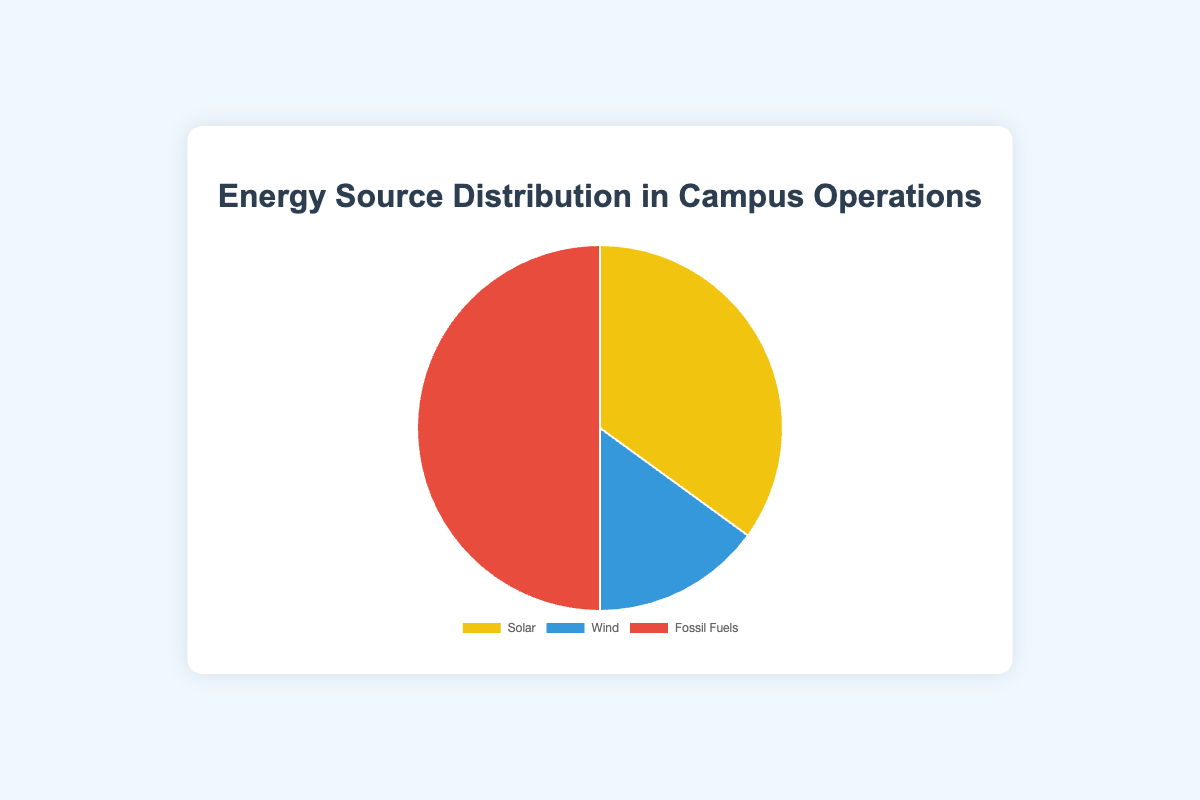What percentage of the campus energy supply is from renewable sources? Renewable sources include Solar and Wind. According to the data, Solar provides 35% and Wind provides 15%. Adding these together, the total contribution from renewable sources is 35% + 15% = 50%.
Answer: 50% Which energy source provides the highest percentage of the campus energy supply? According to the data, Fossil Fuels provide 50%, which is higher than Solar (35%) and Wind (15%). Therefore, the highest percentage is provided by Fossil Fuels.
Answer: Fossil Fuels What is the difference in the energy supply percentages between the Solar and Wind sources? According to the data, Solar provides 35% and Wind provides 15%. The difference between these two percentages is 35% - 15% = 20%.
Answer: 20% By how much does the percentage of energy from Fossil Fuels exceed the combined percentage of Solar and Wind energy? The combined percentage of Solar and Wind is 35% + 15% = 50%. The percentage from Fossil Fuels is also 50%. The difference is 50% - 50% = 0%.
Answer: 0% Which segment of the pie chart is depicted in yellow? According to the configuration, the background color for Solar is specified first, which is yellow. Therefore, the yellow segment represents Solar energy.
Answer: Solar What visual characteristic differentiates the Fossil Fuels segment from others on the pie chart? The Fossil Fuels segment is represented by the color red, as opposed to yellow for Solar and blue for Wind. This makes the Fossil Fuels segment visually identifiable by its red color.
Answer: Red If the percentage of energy from Wind were to double, what would be the new percentage distribution for each energy source? Doubling the Wind energy from 15% results in 15% * 2 = 30%. The remaining energy supply percentage is 100% - 30% = 70%. Splitting this equally between Solar and Fossil Fuels, Solar would be 70% * (35/85) ≈ 28.24% and Fossil Fuels would be 70% * (50/85) ≈ 41.76%. Therefore, the new percentages would be approximately Solar 28.24%, Wind 30%, and Fossil Fuels 41.76%.
Answer: Solar ~28.24%, Wind 30%, Fossil Fuels ~41.76% How does the contribution of Wind energy compare to the contribution of Solar energy? According to the data, Wind contributes 15% while Solar contributes 35%. Comparing these values, Solar energy contributes more than twice as much as Wind energy.
Answer: Solar > Wind 